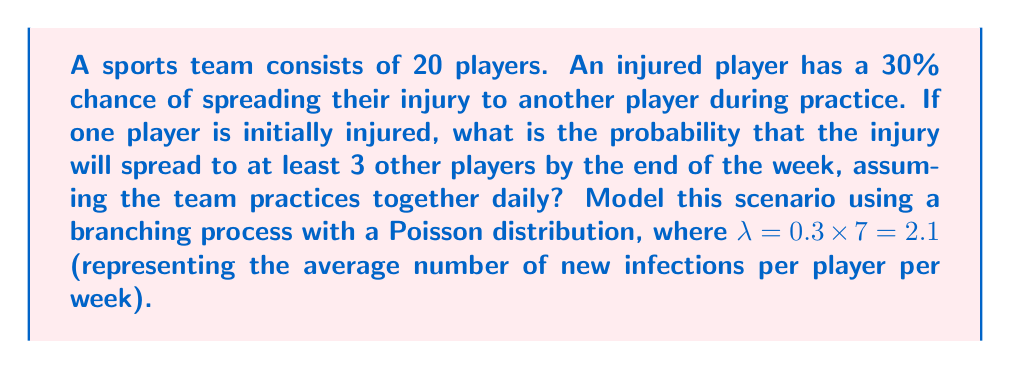Can you answer this question? Let's approach this step-by-step using a branching process model:

1) First, we need to calculate the probability of an infected player spreading the injury to exactly 0, 1, and 2 other players within a week. We'll use the Poisson distribution with $\lambda = 2.1$:

   $P(X = k) = \frac{e^{-\lambda} \lambda^k}{k!}$

   $P(X = 0) = \frac{e^{-2.1} 2.1^0}{0!} \approx 0.1225$
   $P(X = 1) = \frac{e^{-2.1} 2.1^1}{1!} \approx 0.2572$
   $P(X = 2) = \frac{e^{-2.1} 2.1^2}{2!} \approx 0.2700$

2) The probability of spreading to 3 or more players is:
   
   $P(X \geq 3) = 1 - P(X < 3) = 1 - [P(X = 0) + P(X = 1) + P(X = 2)]$
   $= 1 - (0.1225 + 0.2572 + 0.2700) \approx 0.3503$

3) Now, we can model this as a branching process. Let $q$ be the probability that the process becomes extinct (i.e., the injury doesn't spread to 3 or more players). We can write a self-consistency equation:

   $q = 0.1225 + 0.2572q + 0.2700q^2 + 0.3503q^3$

4) Solving this equation numerically (using methods like Newton-Raphson), we get:

   $q \approx 0.4037$

5) Therefore, the probability that the injury spreads to at least 3 other players is:

   $1 - q \approx 1 - 0.4037 = 0.5963$
Answer: 0.5963 